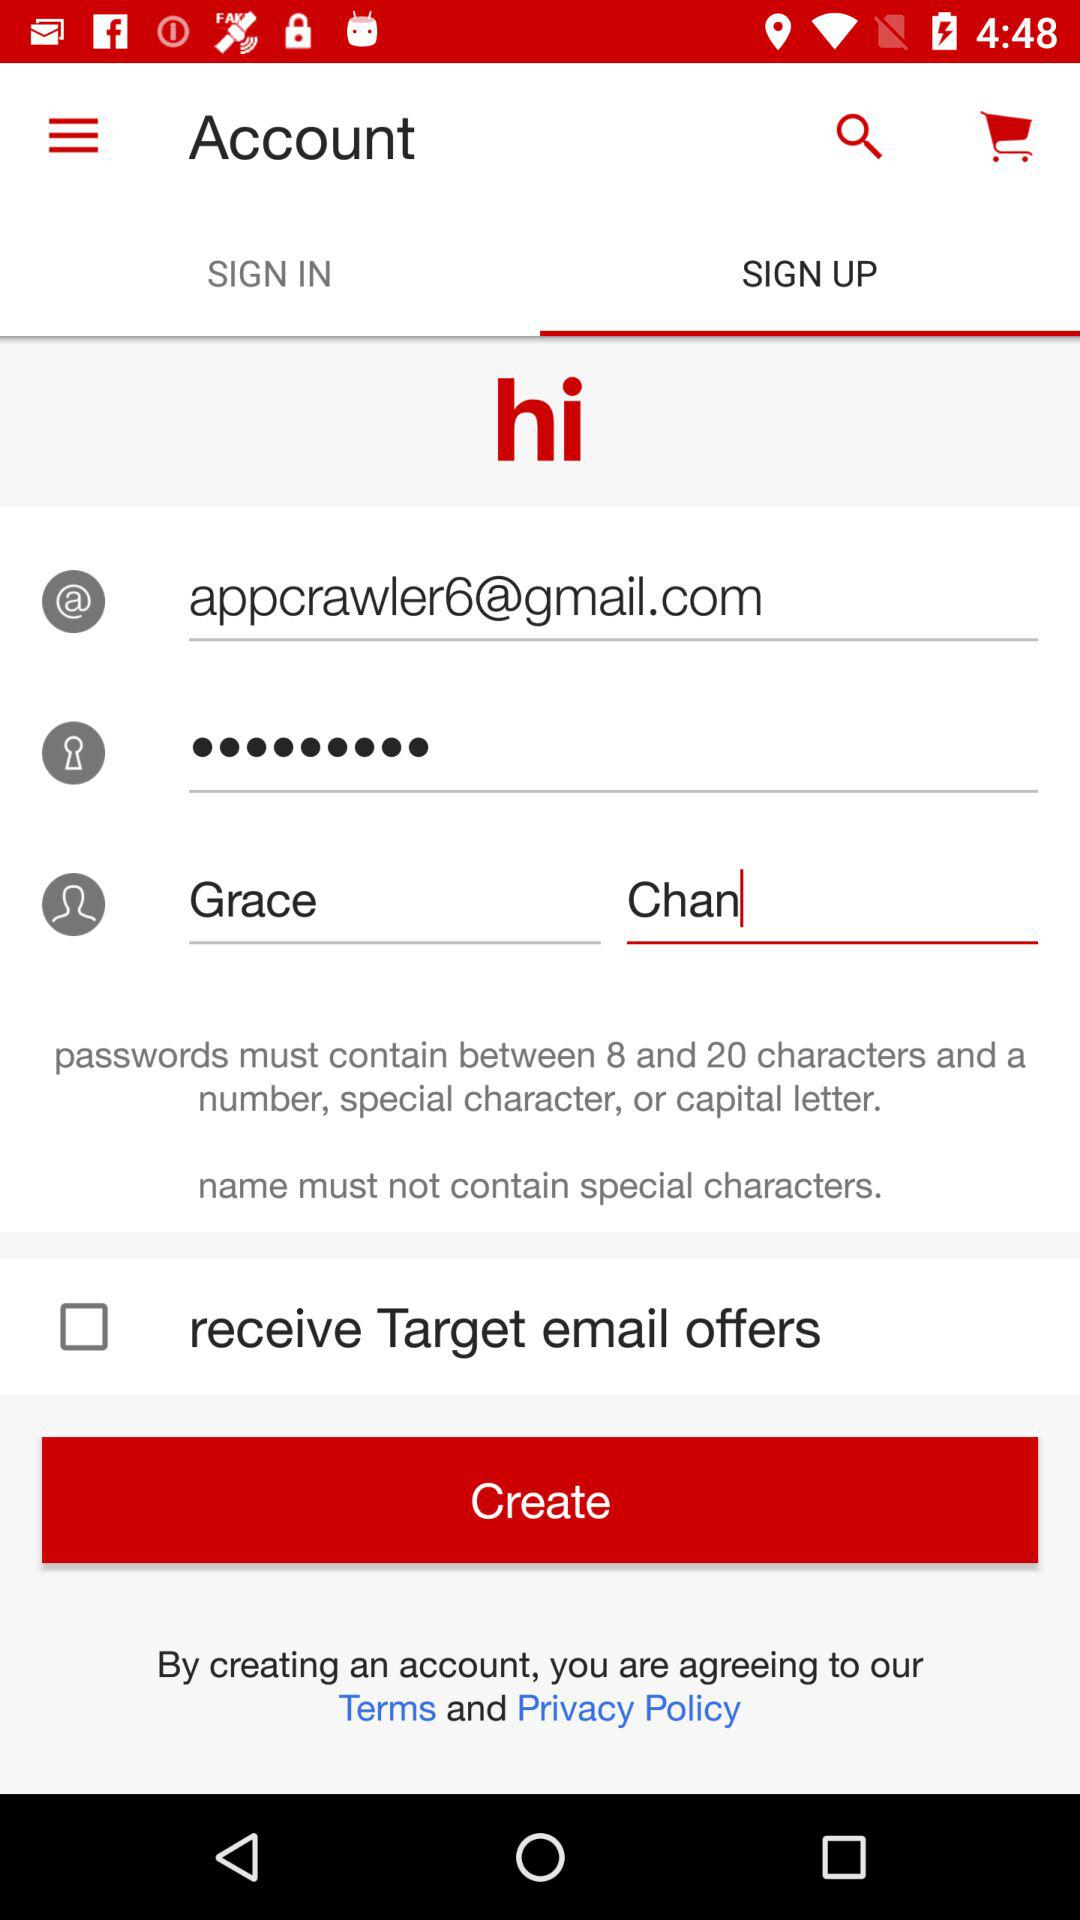Which application is shown here?
When the provided information is insufficient, respond with <no answer>. <no answer> 